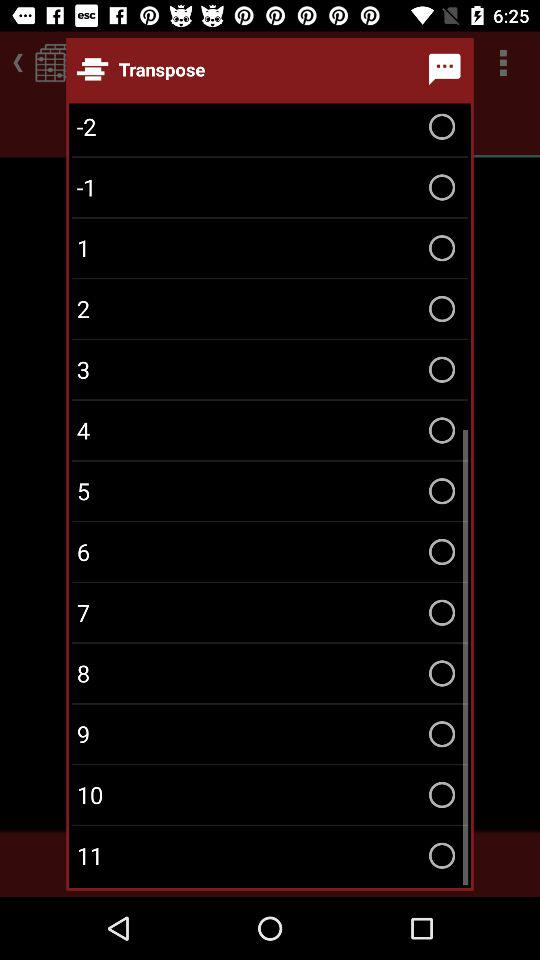Which option is selected?
When the provided information is insufficient, respond with <no answer>. <no answer> 